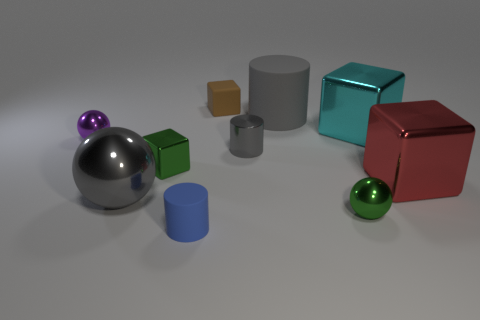Subtract all blue cubes. Subtract all gray cylinders. How many cubes are left? 4 Subtract all cubes. How many objects are left? 6 Add 6 gray metal cylinders. How many gray metal cylinders are left? 7 Add 5 big cyan matte balls. How many big cyan matte balls exist? 5 Subtract 0 purple cylinders. How many objects are left? 10 Subtract all big yellow metal cylinders. Subtract all large red metal things. How many objects are left? 9 